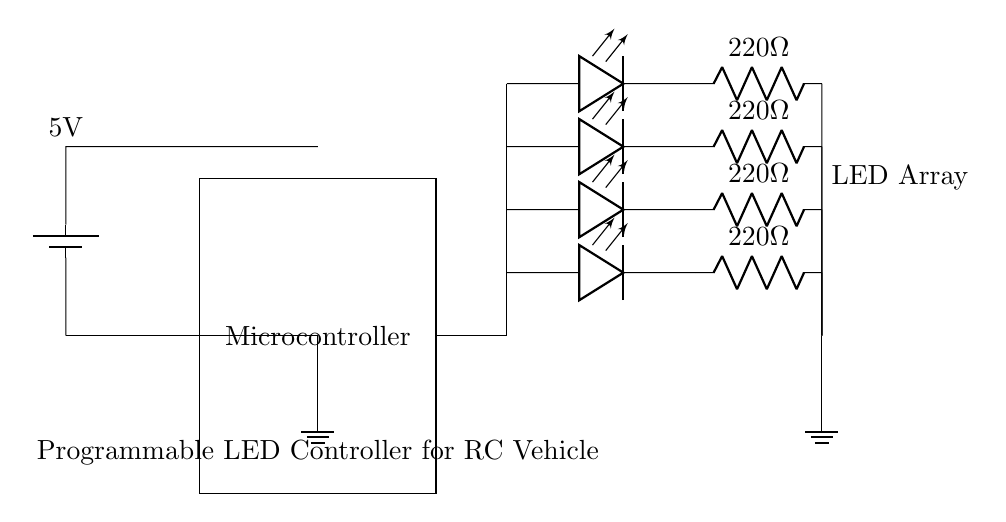What is the main component controlling the LED sequences? The main component is the microcontroller, which is responsible for programming and managing the LED lighting sequences. It connects to each LED to control their operation.
Answer: Microcontroller What is the power supply voltage for this circuit? The power supply voltage is indicated as 5V in the diagram, which is necessary to operate the microcontroller and the LEDs.
Answer: 5V How many LEDs are included in this setup? There are four LEDs in the circuit, as shown by the distinct LED symbols drawn vertically in the diagram.
Answer: Four What is the resistance value used for the LED current limiting? The resistance value used for current limiting is 220 Ohms, as denoted next to the resistor symbols in the circuit.
Answer: 220 Ohm How are the LEDs connected to the microcontroller? The LEDs are connected to the microcontroller through paths that branch out from the microcontroller’s east side, which allows the microcontroller to control them individually.
Answer: Branching connections What does the ground symbol represent in this circuit? The ground symbol represents the common reference point for the circuit, ensuring that all voltages are measured relative to this point, providing a stable operating condition for components.
Answer: Common reference point 